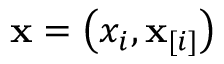<formula> <loc_0><loc_0><loc_500><loc_500>x = \left ( x _ { i } , x _ { [ i ] } \right )</formula> 